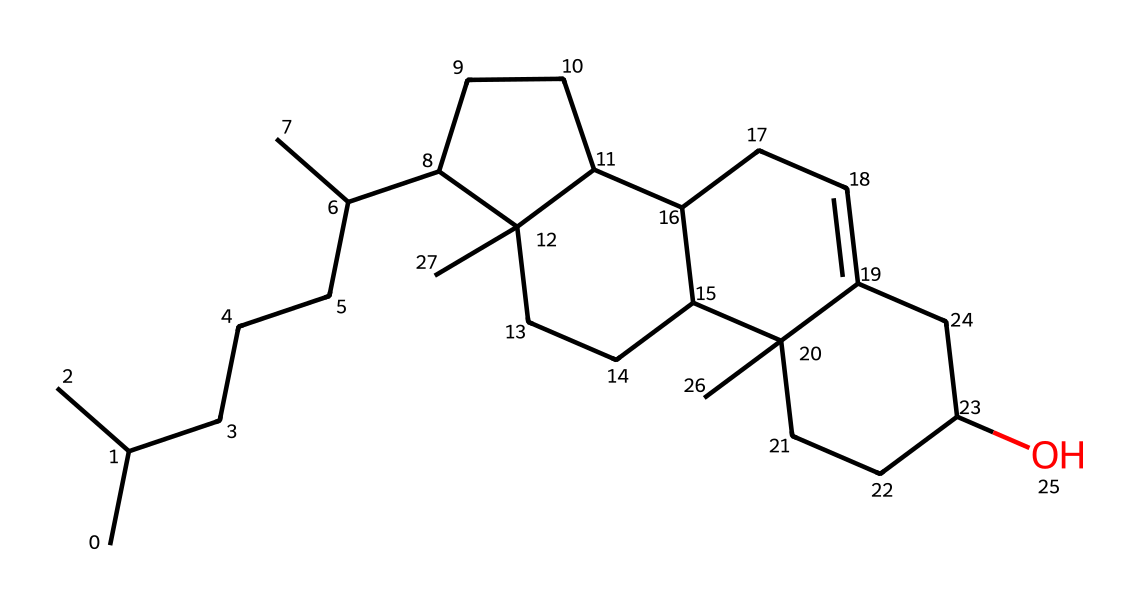What is the molecular formula of cholesterol? The SMILES representation breaks down to indicate each element's quantity. Counting the carbon (C), hydrogen (H), and oxygen (O) atoms gives the formula C27H46O.
Answer: C27H46O How many rings are present in the chemical structure of cholesterol? Analyzing the structure, we observe that cholesterol has four interconnected carbon rings in its structure based on the cyclical arrangement shown in the SMILES.
Answer: 4 What is the primary functional group present in cholesterol? From the SMILES representation, the presence of an "O" indicates that there is a hydroxyl (-OH) group attached, making it an alcohol.
Answer: hydroxyl group How many carbon atoms are in the molecular structure of cholesterol? By observing the structure indicated in the SMILES, I count a total of 27 carbon atoms based on the notation used.
Answer: 27 What type of lipid is represented by this structure? The structure is characteristic of sterols, which are a subgroup of steroids. The ring structure and hydroxyl group confirm that it is a sterol.
Answer: sterol Which qualities of cholesterol contribute to its role in cell membranes? The rigid ring structure provides stability while the hydroxyl group enhances interaction with the phospholipid bilayer, making it amphipathic, which is crucial for membrane fluidity.
Answer: amphipathic 